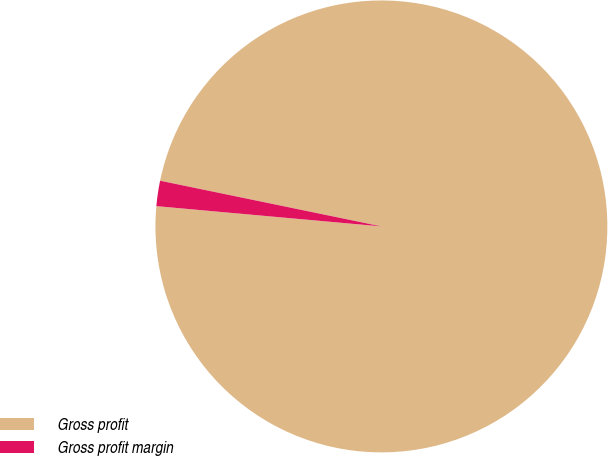Convert chart. <chart><loc_0><loc_0><loc_500><loc_500><pie_chart><fcel>Gross profit<fcel>Gross profit margin<nl><fcel>98.19%<fcel>1.81%<nl></chart> 